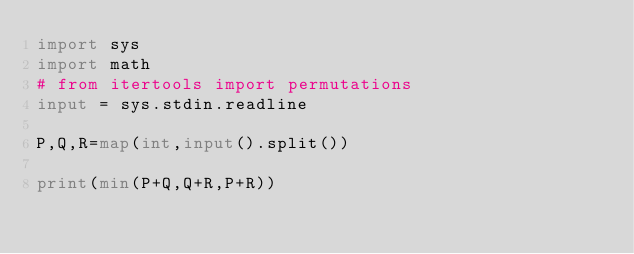Convert code to text. <code><loc_0><loc_0><loc_500><loc_500><_Python_>import sys
import math
# from itertools import permutations
input = sys.stdin.readline

P,Q,R=map(int,input().split())

print(min(P+Q,Q+R,P+R))</code> 